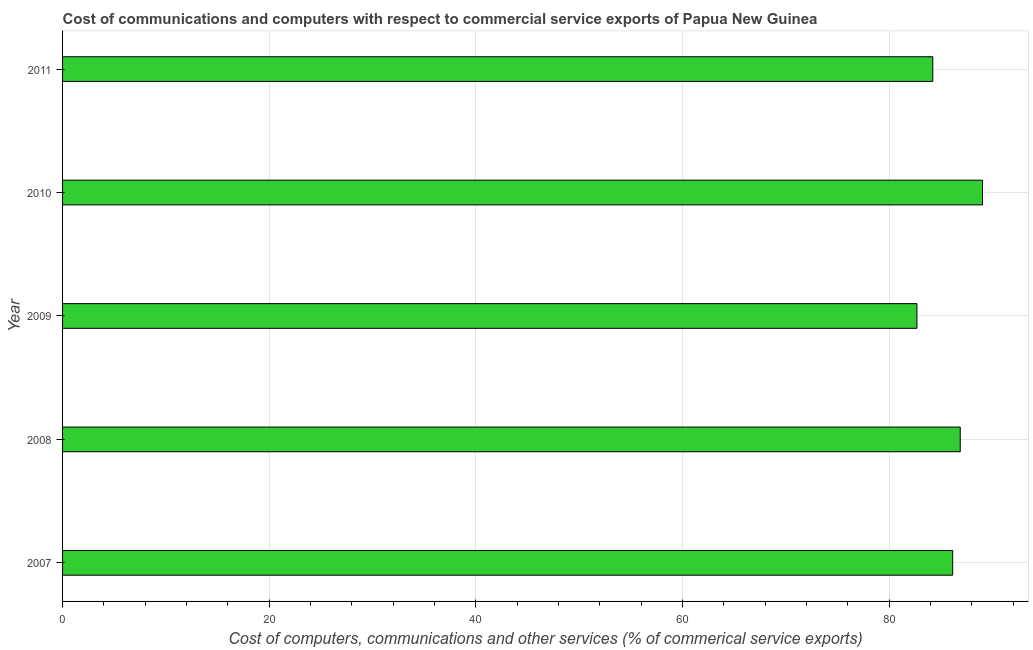Does the graph contain any zero values?
Offer a terse response. No. Does the graph contain grids?
Your response must be concise. Yes. What is the title of the graph?
Ensure brevity in your answer.  Cost of communications and computers with respect to commercial service exports of Papua New Guinea. What is the label or title of the X-axis?
Provide a short and direct response. Cost of computers, communications and other services (% of commerical service exports). What is the cost of communications in 2011?
Ensure brevity in your answer.  84.21. Across all years, what is the maximum cost of communications?
Offer a terse response. 89.03. Across all years, what is the minimum  computer and other services?
Keep it short and to the point. 82.68. In which year was the  computer and other services maximum?
Make the answer very short. 2010. In which year was the cost of communications minimum?
Make the answer very short. 2009. What is the sum of the  computer and other services?
Keep it short and to the point. 428.93. What is the difference between the cost of communications in 2009 and 2010?
Keep it short and to the point. -6.34. What is the average  computer and other services per year?
Your answer should be very brief. 85.79. What is the median cost of communications?
Make the answer very short. 86.14. Do a majority of the years between 2009 and 2010 (inclusive) have  computer and other services greater than 68 %?
Ensure brevity in your answer.  Yes. Is the difference between the  computer and other services in 2010 and 2011 greater than the difference between any two years?
Provide a short and direct response. No. What is the difference between the highest and the second highest  computer and other services?
Give a very brief answer. 2.15. Is the sum of the cost of communications in 2007 and 2010 greater than the maximum cost of communications across all years?
Offer a terse response. Yes. What is the difference between the highest and the lowest  computer and other services?
Keep it short and to the point. 6.35. How many bars are there?
Provide a succinct answer. 5. Are all the bars in the graph horizontal?
Offer a very short reply. Yes. How many years are there in the graph?
Provide a succinct answer. 5. What is the difference between two consecutive major ticks on the X-axis?
Your answer should be compact. 20. What is the Cost of computers, communications and other services (% of commerical service exports) in 2007?
Your answer should be compact. 86.14. What is the Cost of computers, communications and other services (% of commerical service exports) of 2008?
Keep it short and to the point. 86.87. What is the Cost of computers, communications and other services (% of commerical service exports) in 2009?
Give a very brief answer. 82.68. What is the Cost of computers, communications and other services (% of commerical service exports) in 2010?
Provide a succinct answer. 89.03. What is the Cost of computers, communications and other services (% of commerical service exports) in 2011?
Ensure brevity in your answer.  84.21. What is the difference between the Cost of computers, communications and other services (% of commerical service exports) in 2007 and 2008?
Ensure brevity in your answer.  -0.73. What is the difference between the Cost of computers, communications and other services (% of commerical service exports) in 2007 and 2009?
Make the answer very short. 3.46. What is the difference between the Cost of computers, communications and other services (% of commerical service exports) in 2007 and 2010?
Your answer should be very brief. -2.88. What is the difference between the Cost of computers, communications and other services (% of commerical service exports) in 2007 and 2011?
Provide a succinct answer. 1.93. What is the difference between the Cost of computers, communications and other services (% of commerical service exports) in 2008 and 2009?
Your answer should be very brief. 4.19. What is the difference between the Cost of computers, communications and other services (% of commerical service exports) in 2008 and 2010?
Your answer should be compact. -2.15. What is the difference between the Cost of computers, communications and other services (% of commerical service exports) in 2008 and 2011?
Ensure brevity in your answer.  2.66. What is the difference between the Cost of computers, communications and other services (% of commerical service exports) in 2009 and 2010?
Keep it short and to the point. -6.35. What is the difference between the Cost of computers, communications and other services (% of commerical service exports) in 2009 and 2011?
Your answer should be compact. -1.53. What is the difference between the Cost of computers, communications and other services (% of commerical service exports) in 2010 and 2011?
Provide a succinct answer. 4.81. What is the ratio of the Cost of computers, communications and other services (% of commerical service exports) in 2007 to that in 2008?
Provide a succinct answer. 0.99. What is the ratio of the Cost of computers, communications and other services (% of commerical service exports) in 2007 to that in 2009?
Offer a very short reply. 1.04. What is the ratio of the Cost of computers, communications and other services (% of commerical service exports) in 2007 to that in 2010?
Offer a terse response. 0.97. What is the ratio of the Cost of computers, communications and other services (% of commerical service exports) in 2008 to that in 2009?
Give a very brief answer. 1.05. What is the ratio of the Cost of computers, communications and other services (% of commerical service exports) in 2008 to that in 2011?
Your answer should be very brief. 1.03. What is the ratio of the Cost of computers, communications and other services (% of commerical service exports) in 2009 to that in 2010?
Your response must be concise. 0.93. What is the ratio of the Cost of computers, communications and other services (% of commerical service exports) in 2010 to that in 2011?
Make the answer very short. 1.06. 